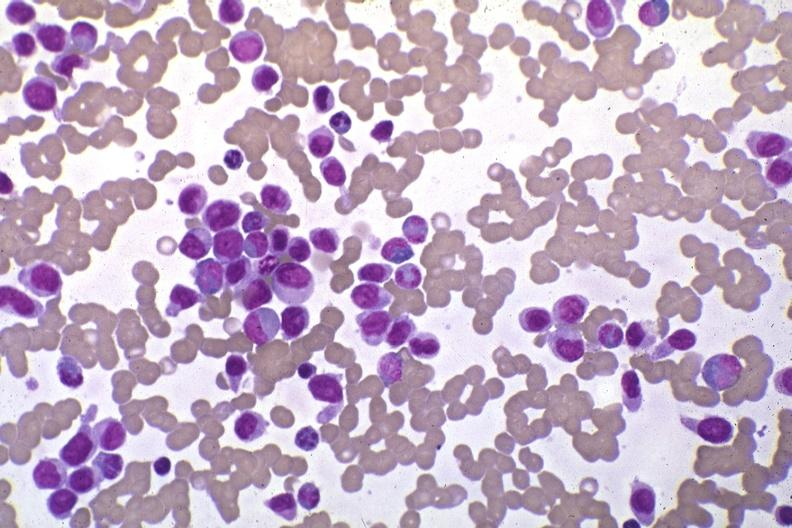s acute monocytic leukemia present?
Answer the question using a single word or phrase. Yes 